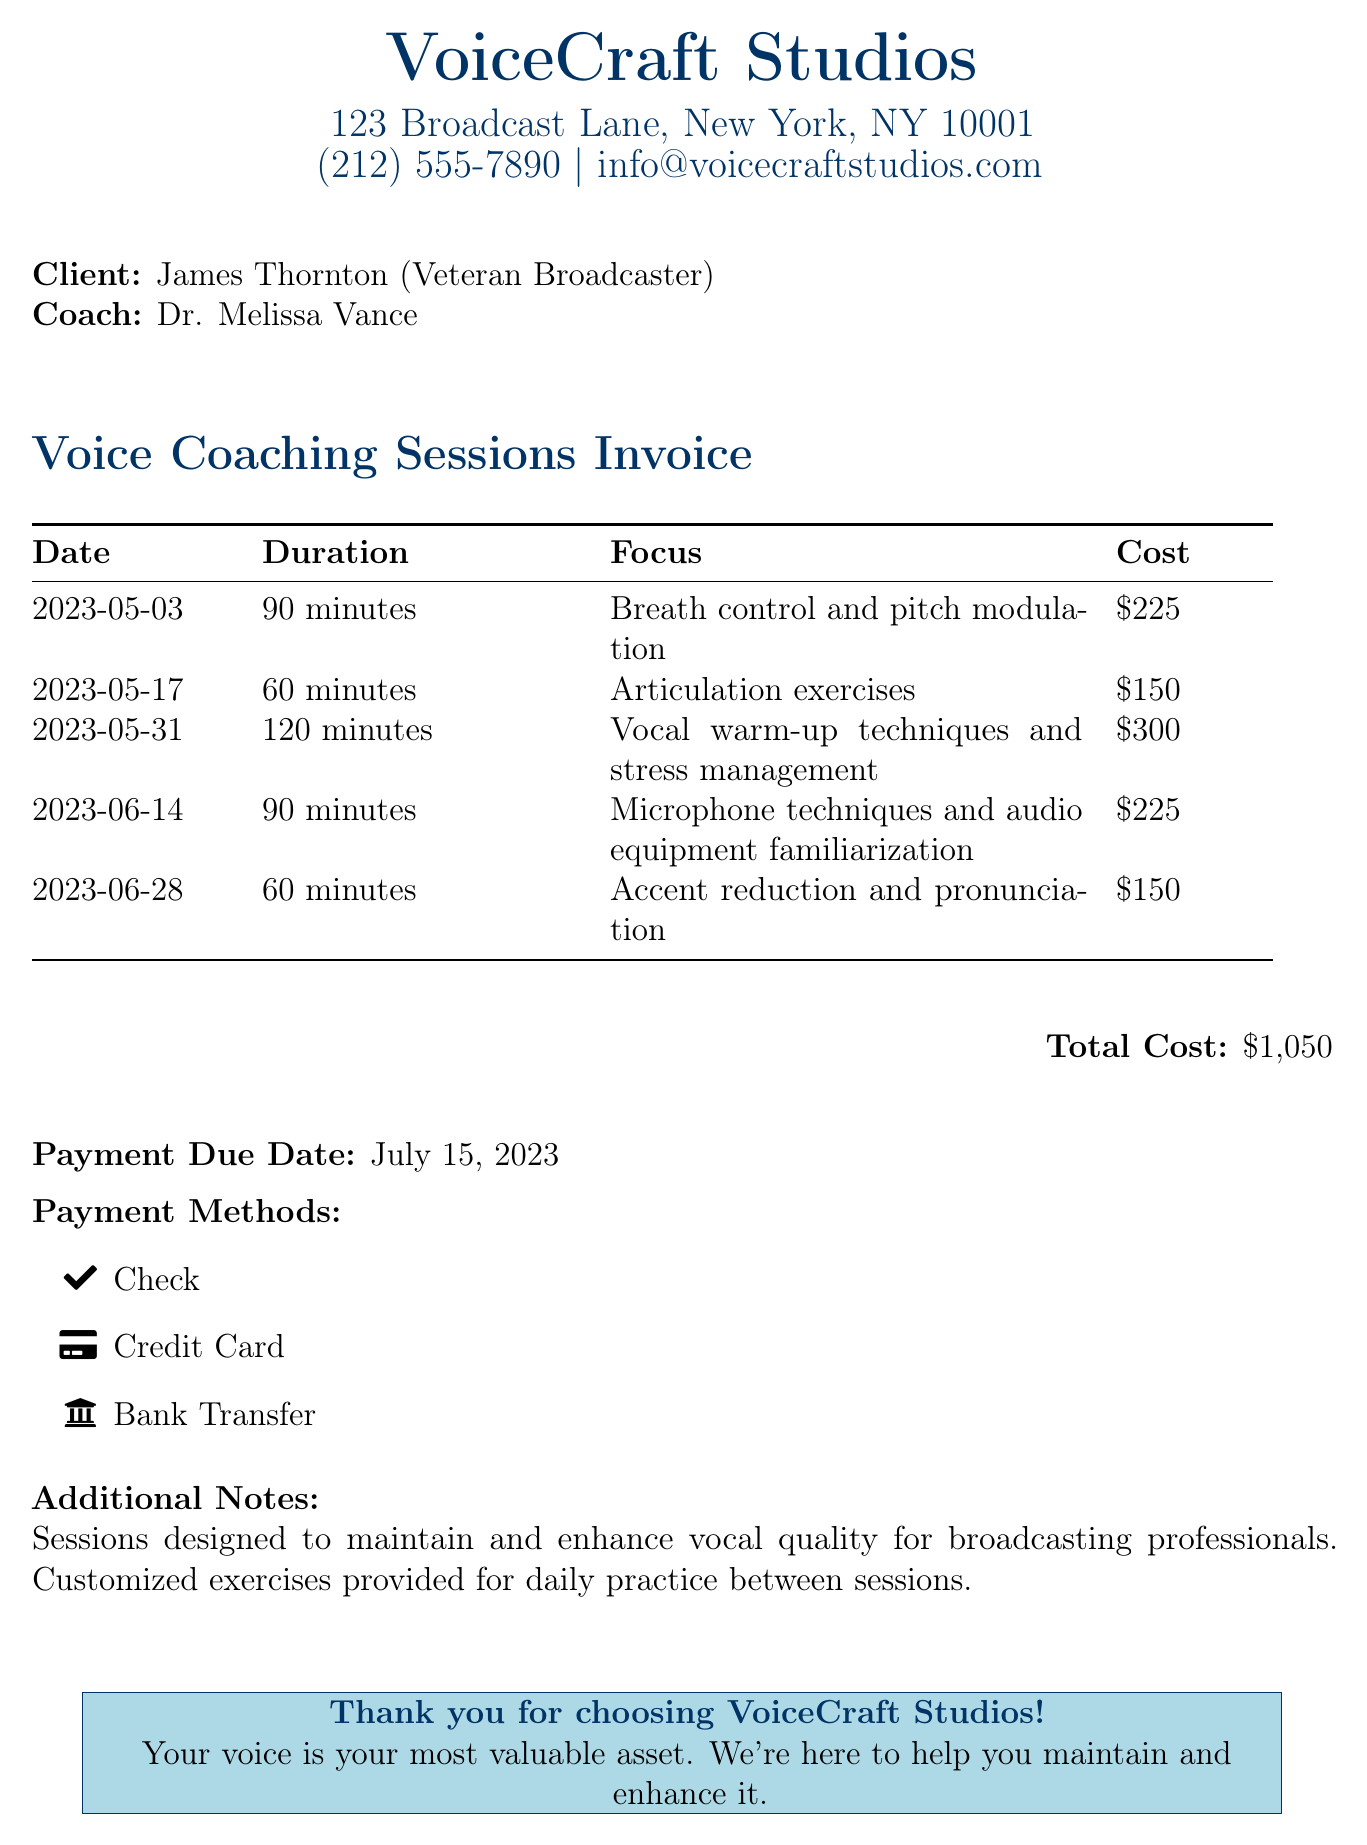What is the name of the studio? The name of the studio is prominently displayed at the top of the document, indicating the service provider.
Answer: VoiceCraft Studios Who is the client? The client’s name is specified in the document, indicating who received the coaching sessions.
Answer: James Thornton What was the focus of the session on May 31, 2023? This information can be found in the table where the date and session details are listed together.
Answer: Vocal warm-up techniques and stress management How much did the session on June 14, 2023, cost? The cost for each session is detailed in the table, corresponding to the specific date.
Answer: $225 What is the total cost for all the sessions? The total cost is summarized in a distinct section, providing a single figure that encapsulates the overall expense.
Answer: $1,050 What payment methods are accepted? The document lists acceptable forms of payment in a dedicated section.
Answer: Check, Credit Card, Bank Transfer On what date is payment due? The due date is clearly stated in the document, indicating when the payment is expected to be made.
Answer: July 15, 2023 How long was the shortest session? The duration of each session is noted, and comparing those values reveals the shortest one.
Answer: 60 minutes 